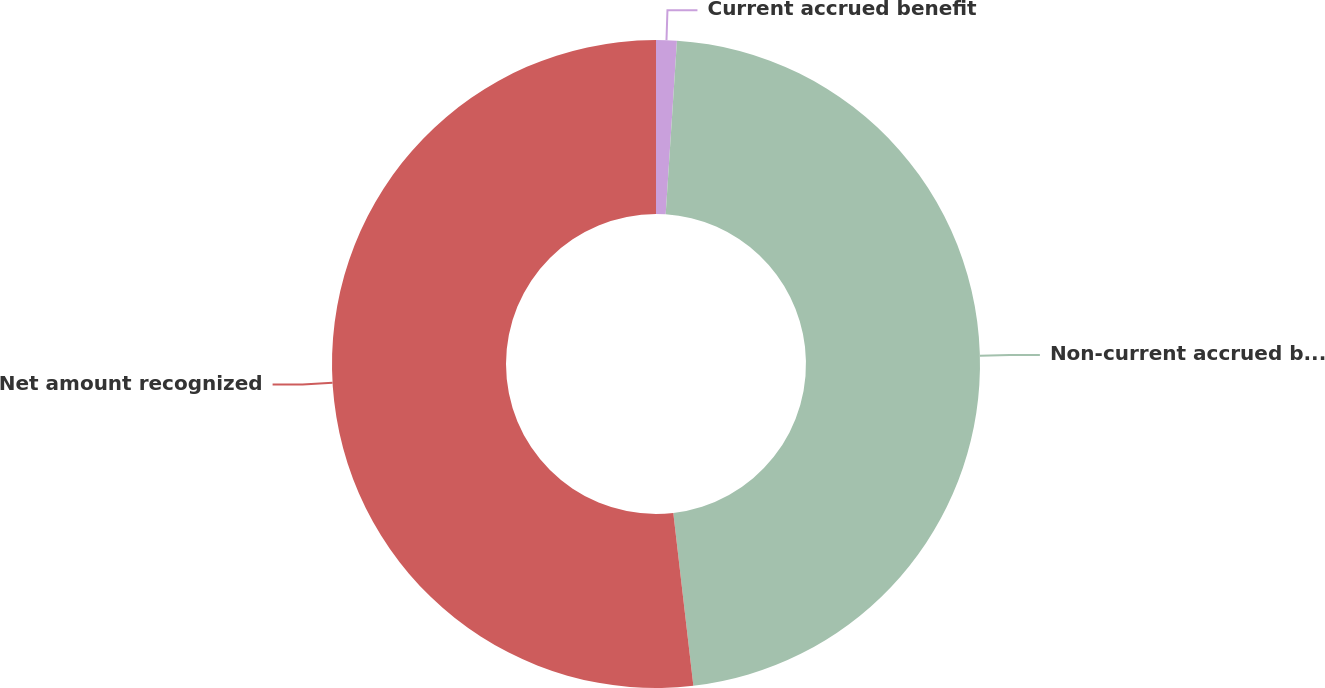<chart> <loc_0><loc_0><loc_500><loc_500><pie_chart><fcel>Current accrued benefit<fcel>Non-current accrued benefit<fcel>Net amount recognized<nl><fcel>1.03%<fcel>47.13%<fcel>51.84%<nl></chart> 